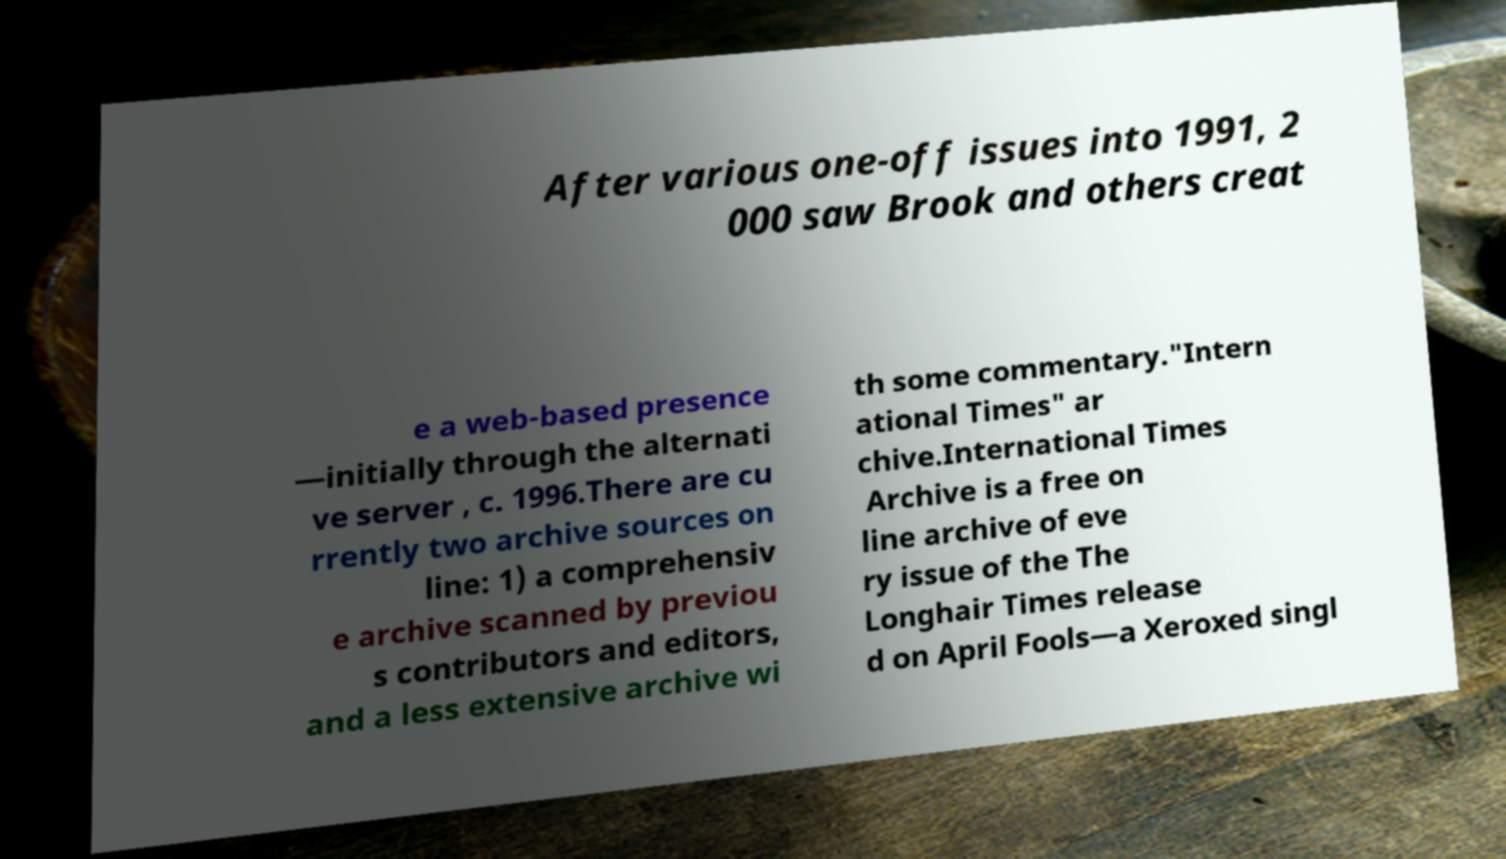Can you accurately transcribe the text from the provided image for me? After various one-off issues into 1991, 2 000 saw Brook and others creat e a web-based presence —initially through the alternati ve server , c. 1996.There are cu rrently two archive sources on line: 1) a comprehensiv e archive scanned by previou s contributors and editors, and a less extensive archive wi th some commentary."Intern ational Times" ar chive.International Times Archive is a free on line archive of eve ry issue of the The Longhair Times release d on April Fools—a Xeroxed singl 